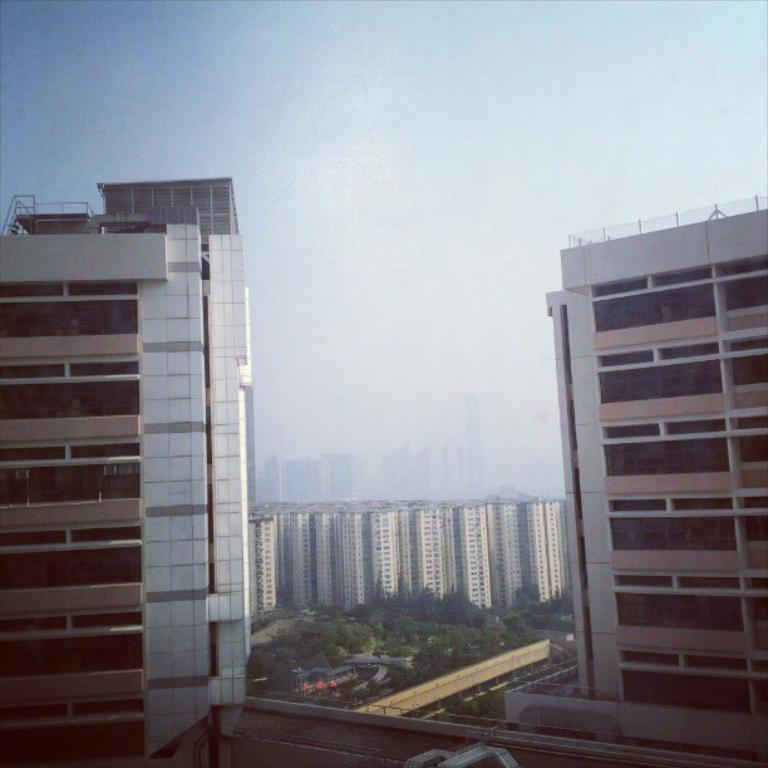What type of structures can be seen in the image? There are buildings in the image. What type of vegetation is present in the image? There are trees in the image. How many leaves can be seen on the trees in the image? There is no specific information about the number of leaves on the trees in the image. Are there any cows visible in the image? There is no mention of cows in the provided facts, so we cannot determine if they are present in the image. 